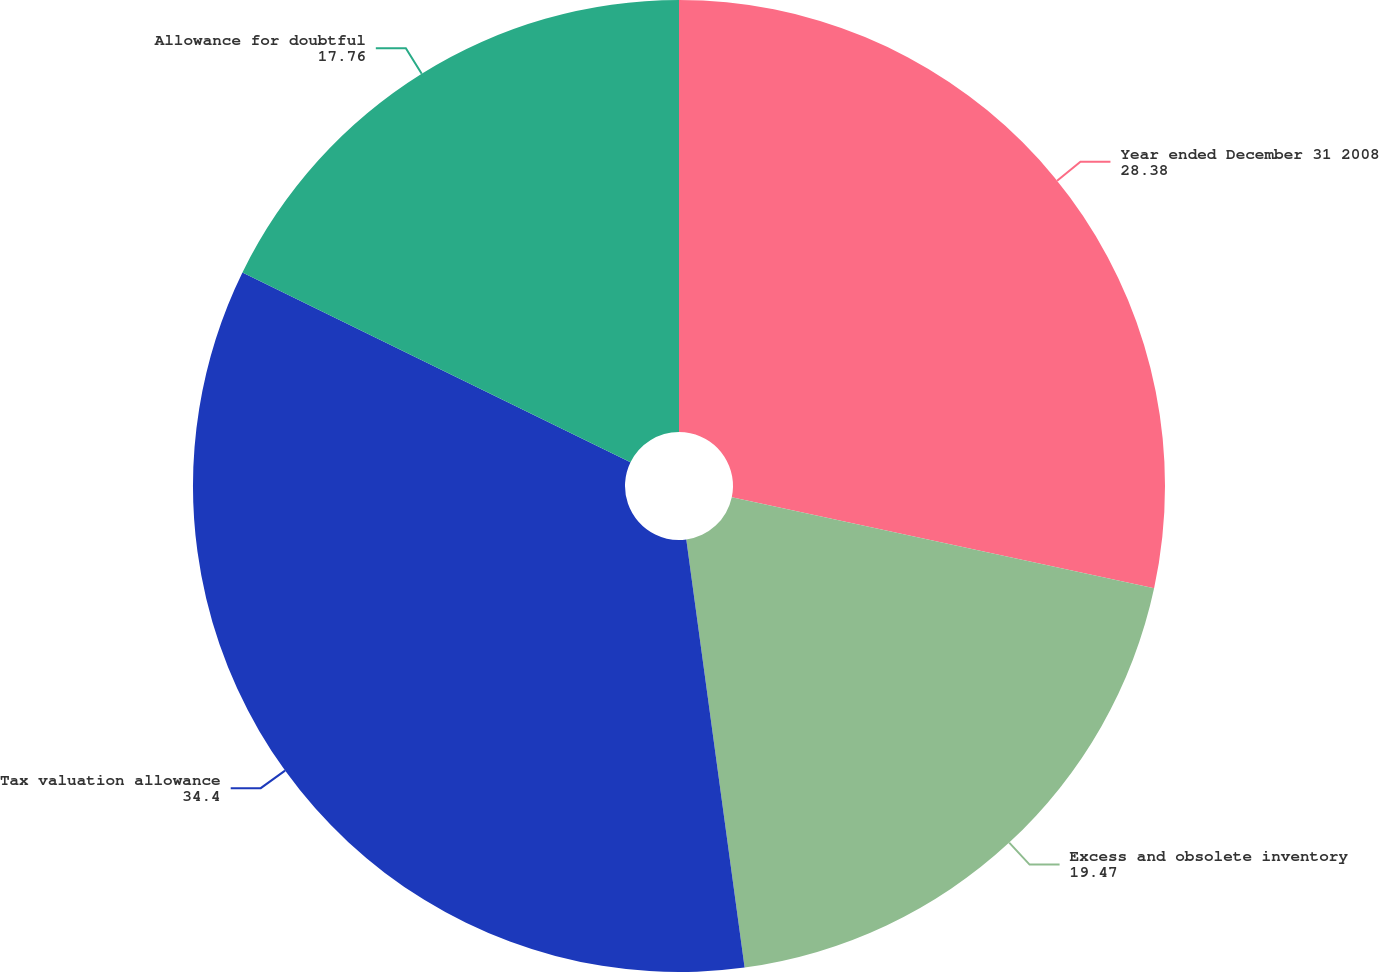Convert chart to OTSL. <chart><loc_0><loc_0><loc_500><loc_500><pie_chart><fcel>Year ended December 31 2008<fcel>Excess and obsolete inventory<fcel>Tax valuation allowance<fcel>Allowance for doubtful<nl><fcel>28.38%<fcel>19.47%<fcel>34.4%<fcel>17.76%<nl></chart> 